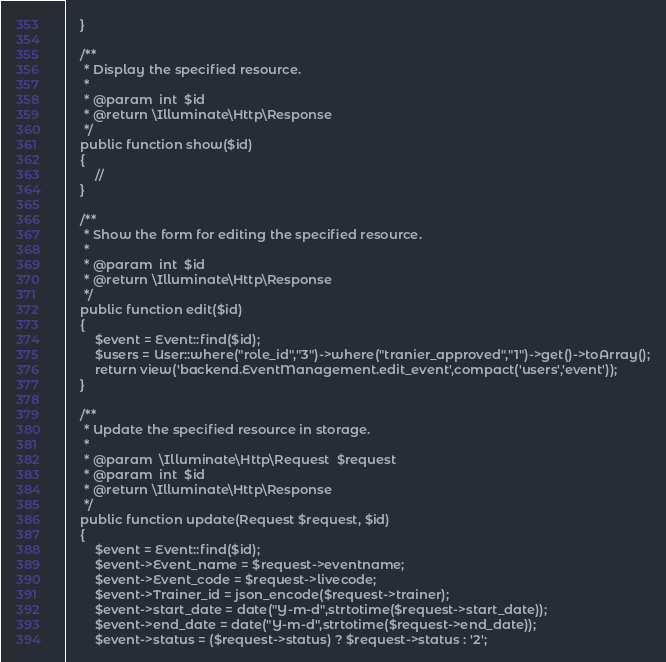<code> <loc_0><loc_0><loc_500><loc_500><_PHP_>	}

	/**
	 * Display the specified resource.
	 *
	 * @param  int  $id
	 * @return \Illuminate\Http\Response
	 */
	public function show($id)
	{
		//
	}

	/**
	 * Show the form for editing the specified resource.
	 *
	 * @param  int  $id
	 * @return \Illuminate\Http\Response
	 */
	public function edit($id)
	{
		$event = Event::find($id);
		$users = User::where("role_id","3")->where("tranier_approved","1")->get()->toArray();
		return view('backend.EventManagement.edit_event',compact('users','event'));
	}

	/**
	 * Update the specified resource in storage.
	 *
	 * @param  \Illuminate\Http\Request  $request
	 * @param  int  $id
	 * @return \Illuminate\Http\Response
	 */
	public function update(Request $request, $id)
	{
		$event = Event::find($id);
		$event->Event_name = $request->eventname;
		$event->Event_code = $request->livecode;
		$event->Trainer_id = json_encode($request->trainer);
		$event->start_date = date("Y-m-d",strtotime($request->start_date));
		$event->end_date = date("Y-m-d",strtotime($request->end_date));
		$event->status = ($request->status) ? $request->status : '2';</code> 